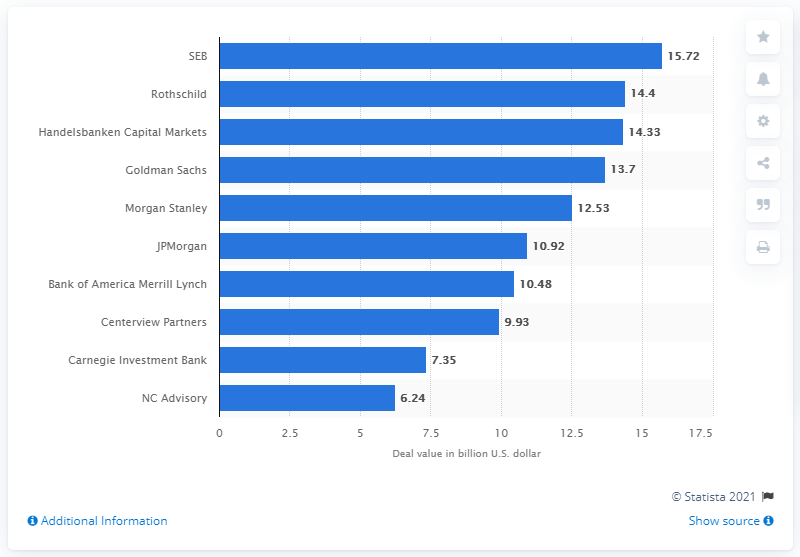Draw attention to some important aspects in this diagram. SEB was the leading advisor to M&A deals in Sweden in 2016. In 2016, the deal value of SEB was 15.72. 